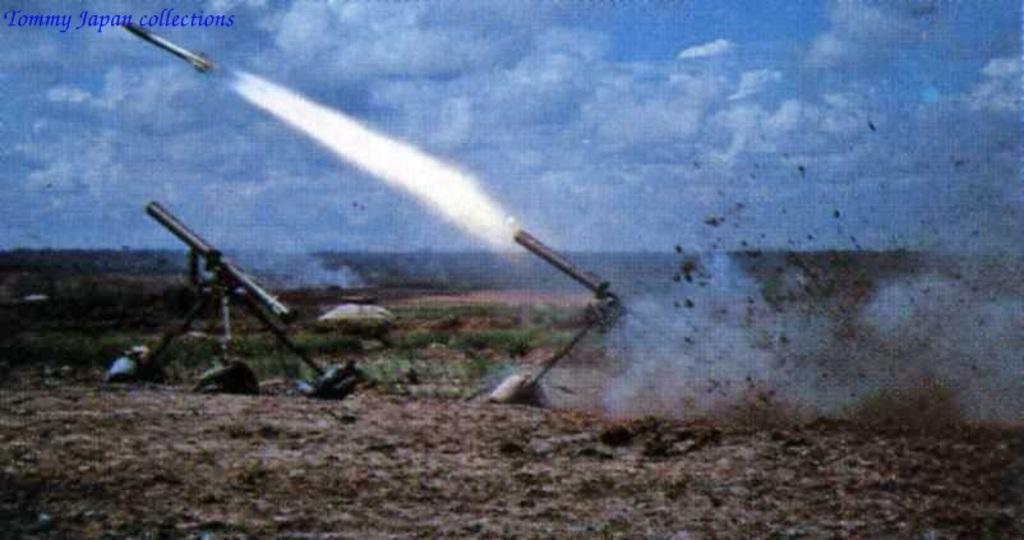What type of machines are present in the image? There are explosion machines in the image. How would you describe the weather based on the image? The sky is cloudy in the image, suggesting a potentially overcast or cloudy day. Can you identify any text or labels in the image? Yes, there is a name in blue color on the left side of the image. What type of lumber is being used to power the explosion machines in the image? There is no lumber present in the image, and the explosion machines are not shown to be powered by any specific fuel source. 